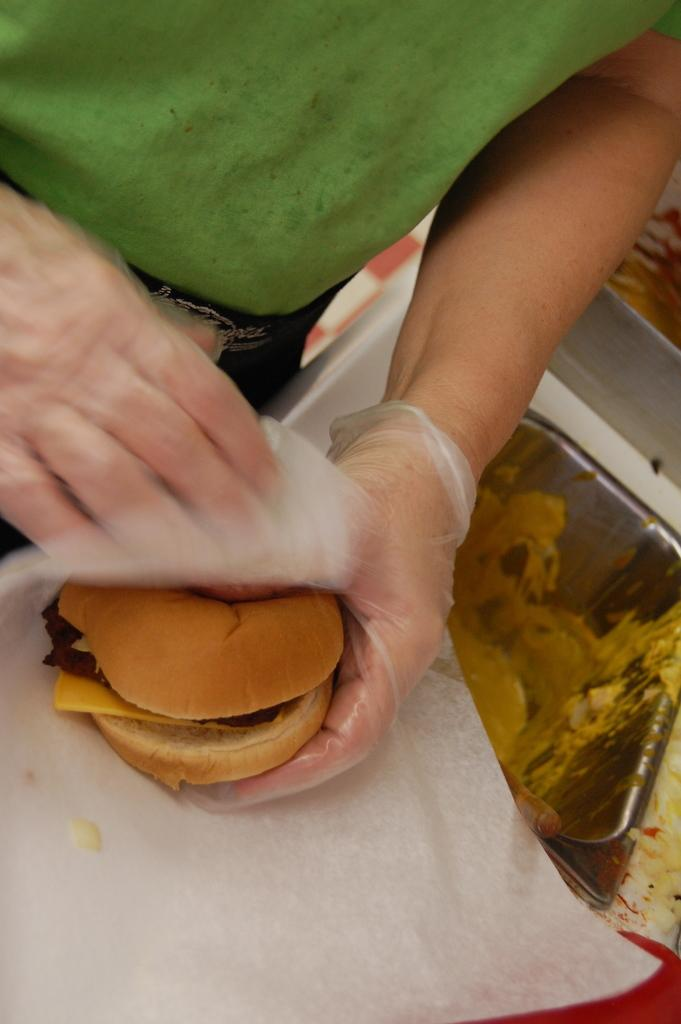What is the main subject of the image? There is a person in the image. What is the person wearing? The person is wearing a green dress. What is the person holding in the image? The person is holding a burger. What can be seen on the right side of the image? There is a box on the right side of the image. What type of peace symbol can be seen in the image? There is no peace symbol present in the image. 